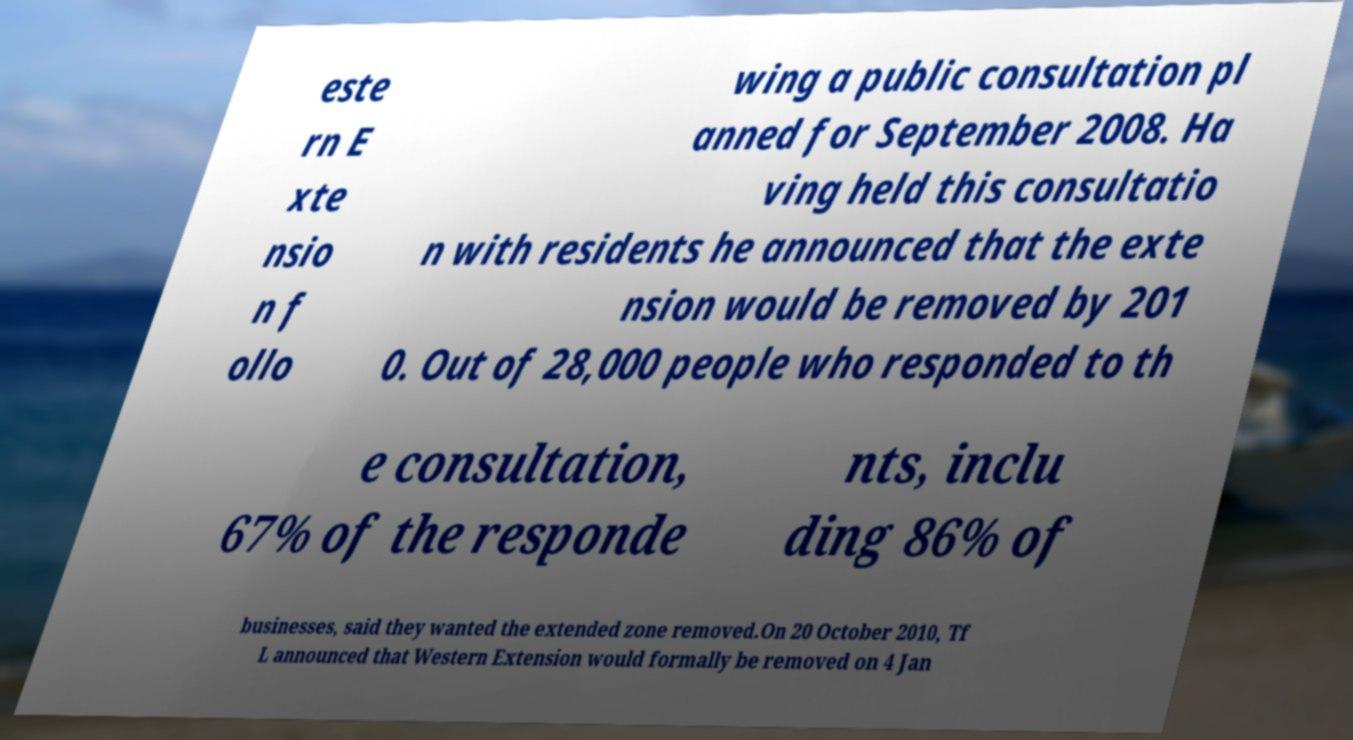Could you assist in decoding the text presented in this image and type it out clearly? este rn E xte nsio n f ollo wing a public consultation pl anned for September 2008. Ha ving held this consultatio n with residents he announced that the exte nsion would be removed by 201 0. Out of 28,000 people who responded to th e consultation, 67% of the responde nts, inclu ding 86% of businesses, said they wanted the extended zone removed.On 20 October 2010, Tf L announced that Western Extension would formally be removed on 4 Jan 